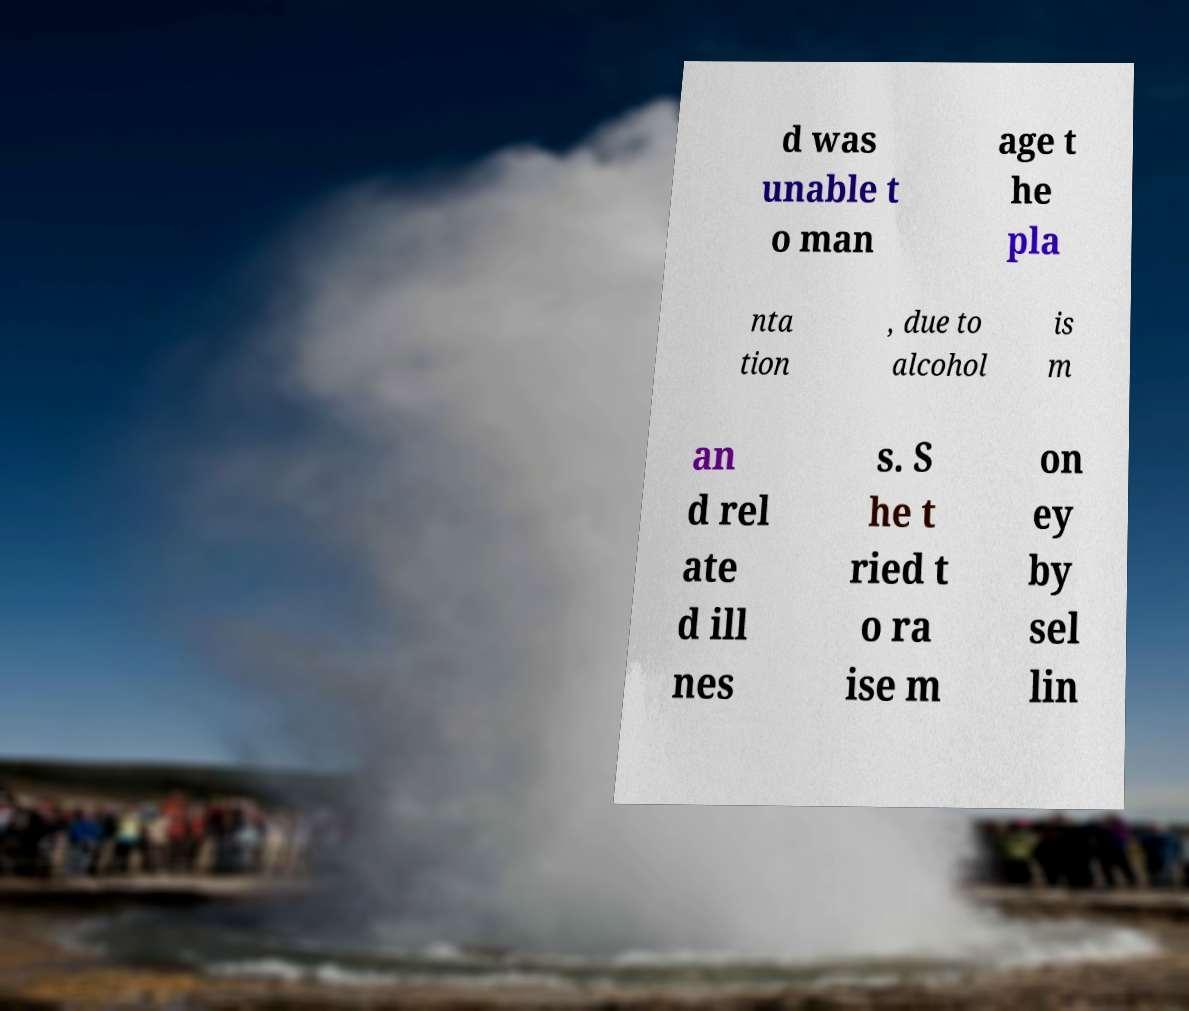Can you read and provide the text displayed in the image?This photo seems to have some interesting text. Can you extract and type it out for me? d was unable t o man age t he pla nta tion , due to alcohol is m an d rel ate d ill nes s. S he t ried t o ra ise m on ey by sel lin 